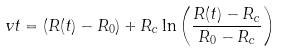<formula> <loc_0><loc_0><loc_500><loc_500>v t = \left ( R ( t ) - R _ { 0 } \right ) + R _ { c } \ln \left ( \frac { R ( t ) - R _ { c } } { R _ { 0 } - R _ { c } } \right )</formula> 